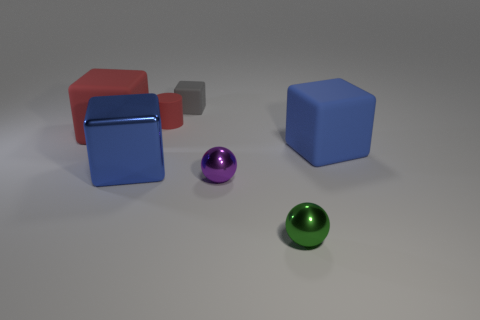Add 1 small gray rubber cubes. How many objects exist? 8 Subtract all spheres. How many objects are left? 5 Add 7 yellow objects. How many yellow objects exist? 7 Subtract 1 red cylinders. How many objects are left? 6 Subtract all small green spheres. Subtract all blue cubes. How many objects are left? 4 Add 3 gray matte blocks. How many gray matte blocks are left? 4 